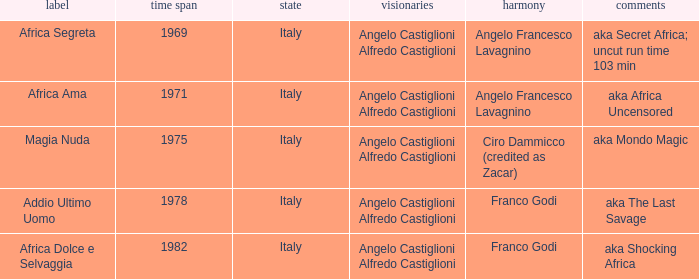How many years have a Title of Magia Nuda? 1.0. 